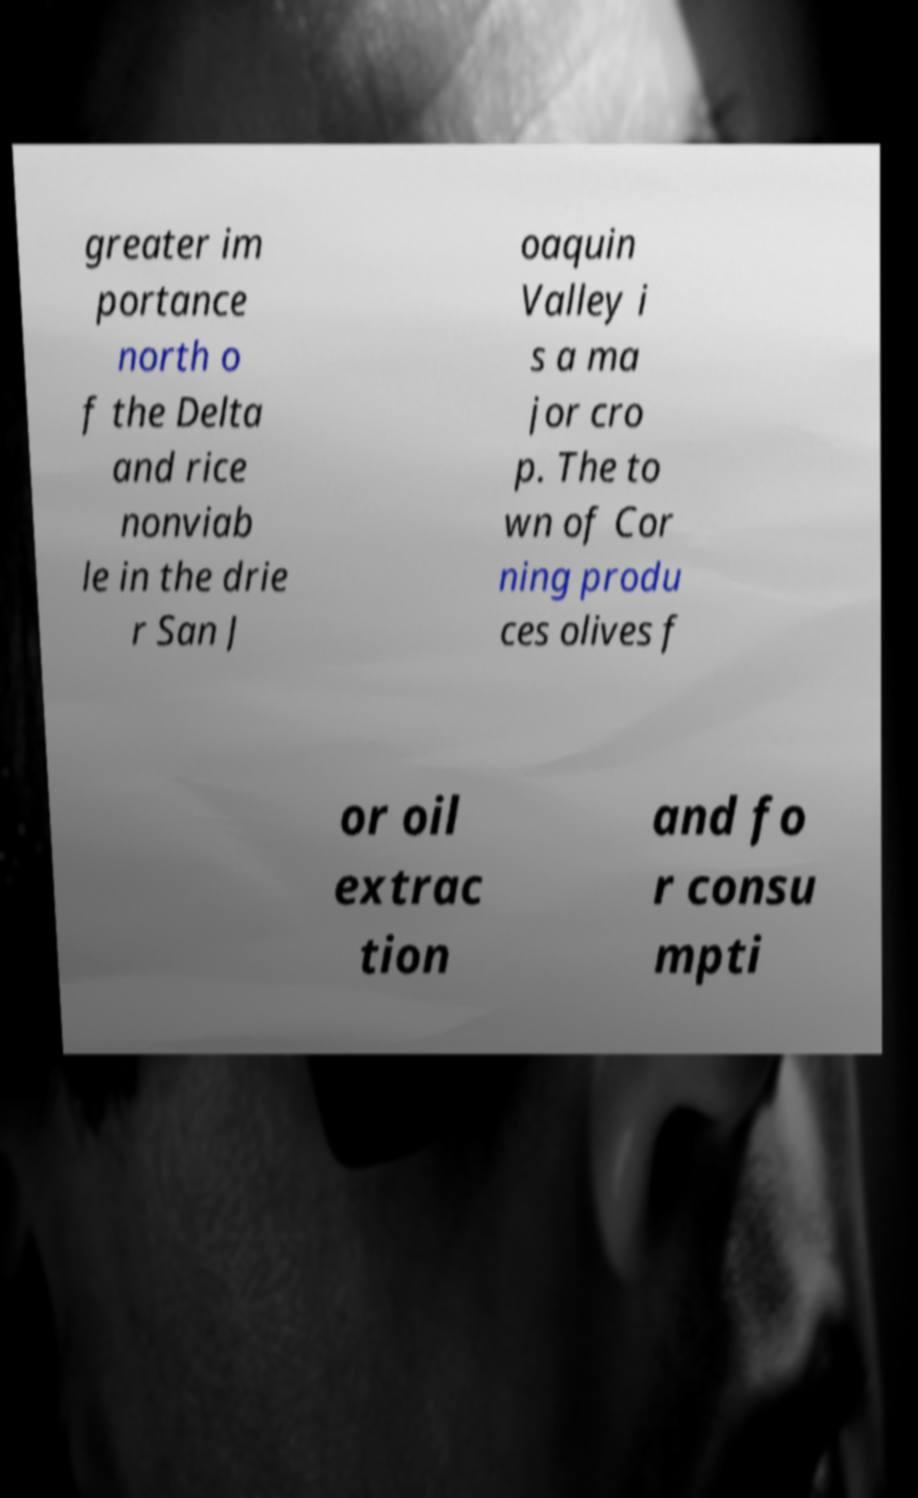Can you accurately transcribe the text from the provided image for me? greater im portance north o f the Delta and rice nonviab le in the drie r San J oaquin Valley i s a ma jor cro p. The to wn of Cor ning produ ces olives f or oil extrac tion and fo r consu mpti 